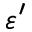Convert formula to latex. <formula><loc_0><loc_0><loc_500><loc_500>\varepsilon ^ { \prime }</formula> 